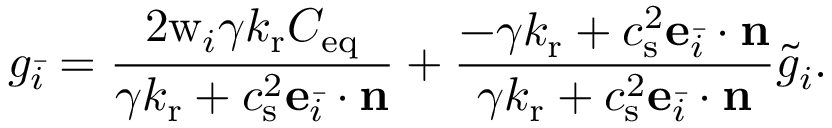Convert formula to latex. <formula><loc_0><loc_0><loc_500><loc_500>g _ { \bar { i } } = \frac { 2 w _ { i } \gamma k _ { r } C _ { e q } } { \gamma k _ { r } + c _ { s } ^ { 2 } e _ { \bar { i } } \cdot n } + \frac { - \gamma k _ { r } + c _ { s } ^ { 2 } e _ { \bar { i } } \cdot n } { \gamma k _ { r } + c _ { s } ^ { 2 } e _ { \bar { i } } \cdot n } \tilde { g } _ { i } .</formula> 